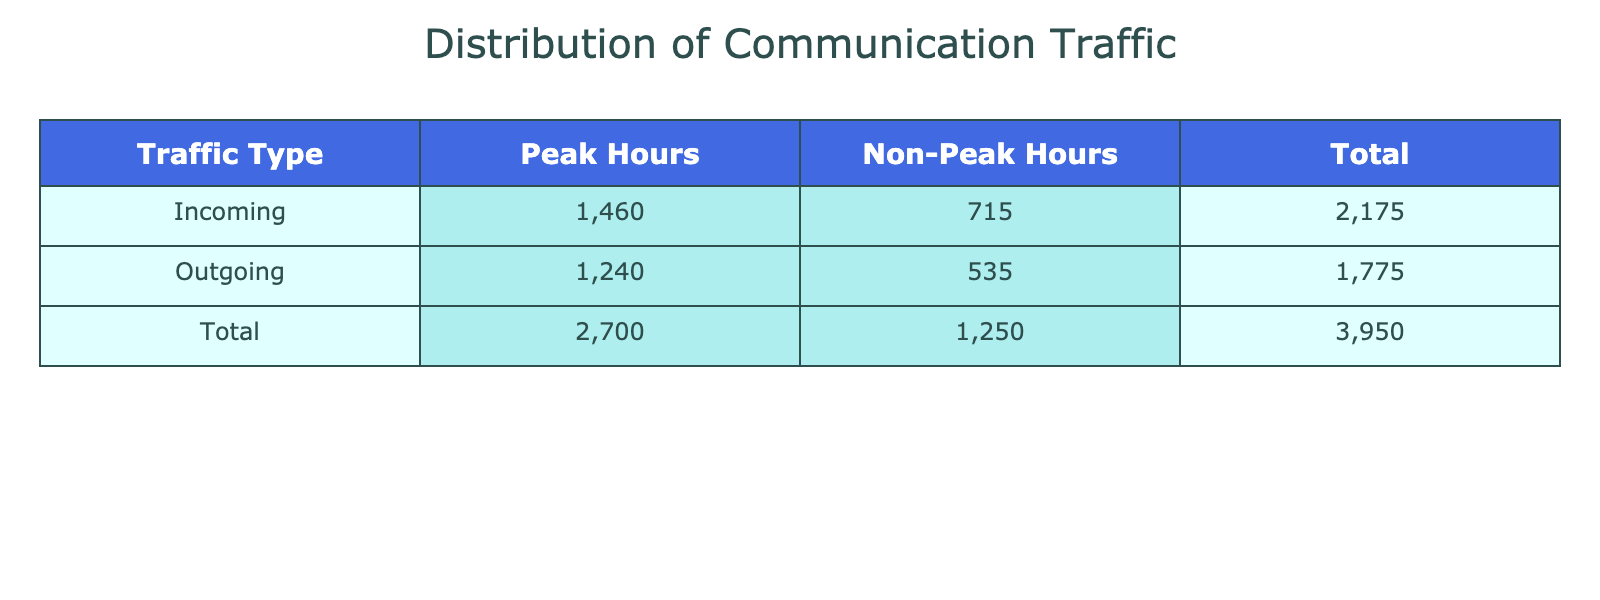What is the total incoming traffic during peak hours? The table indicates the peak incoming traffic values for different hours. Adding the incoming traffic values for peak hours: 70 + 90 + 120 + 150 + 160 + 140 + 130 + 110 + 160 + 180 + 150 = 1,430.
Answer: 1,430 What is the total outgoing traffic during non-peak hours? The table lists the outgoing traffic values for non-peak hours. Summing these values gives: 30 + 25 + 20 + 15 + 10 + 60 + 55 + 50 + 45 = 320.
Answer: 320 Is the incoming traffic during peak hours greater than the total outgoing traffic during the same hours? The total incoming traffic for peak hours is 1,430, while the total outgoing traffic for peak hours is 1,230 (70 + 50 + 100 + 130 + 140 + 120 + 110 + 90 + 140 + 160 + 130). Since 1,430 > 1,230, the statement is true.
Answer: Yes What is the difference between total incoming traffic during peak and non-peak hours? The total incoming traffic during peak hours is 1,430, while the non-peak hours total 380 (50 + 45 + 40 + 35 + 30 + 70 + 65 + 60 + 55). The difference is 1,430 - 380 = 1,050.
Answer: 1,050 What is the average incoming traffic during non-peak hours? The sum of incoming traffic during non-peak hours is 380, and there are 9 data points. The average is 380 / 9 = approximately 42.22.
Answer: Approximately 42.22 How many hours have incoming traffic greater than 100 during peak hours? Review the peak hour traffic values: 70, 90, 120, 150, 160, 140, 130, 110, 160, 180, 150. The hours with values greater than 100 are: 120, 150, 160, 140, 130, 110, 160, 180, 150 (9 instances).
Answer: 9 Which hour has the highest outgoing traffic during peak hours? By looking at peak hours, the outgoing traffic values are: 50, 70, 100, 130, 140, 120, 110, 90, 140, 160, 130. The highest value is 160, occurring at 18:00.
Answer: 18:00 What is the total traffic (incoming + outgoing) during the peak hour at 09:00? The table shows incoming traffic at 09:00 is 160 and outgoing is 140. The total traffic is 160 + 140 = 300.
Answer: 300 During which period is the total communication traffic greater: peak hours or non-peak hours? The total communication traffic during peak hours is 1,430 + 1,230 = 2,660, while for non-peak hours it is 380 + 320 = 700. Comparing 2,660 and 700, peak hours have greater traffic.
Answer: Peak hours 